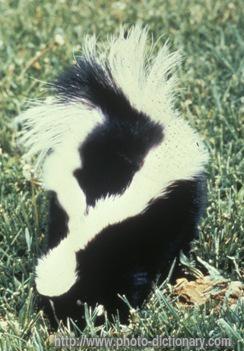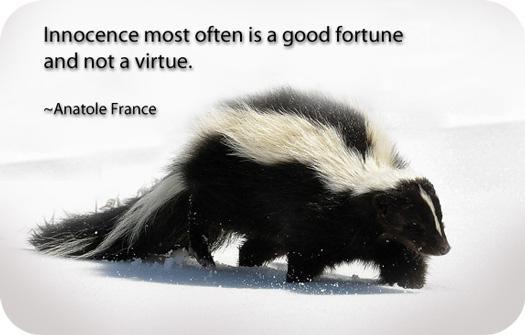The first image is the image on the left, the second image is the image on the right. For the images displayed, is the sentence "All skunks are standing with their bodies in profile and all skunks have their bodies turned in the same direction." factually correct? Answer yes or no. No. The first image is the image on the left, the second image is the image on the right. For the images displayed, is the sentence "In the image to the left, the skunk is standing among some green grass." factually correct? Answer yes or no. Yes. 